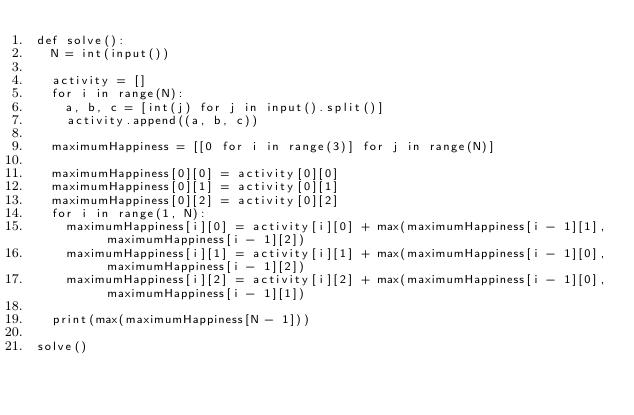Convert code to text. <code><loc_0><loc_0><loc_500><loc_500><_Python_>def solve():
  N = int(input())
  
  activity = []
  for i in range(N):
    a, b, c = [int(j) for j in input().split()]
    activity.append((a, b, c))

  maximumHappiness = [[0 for i in range(3)] for j in range(N)]

  maximumHappiness[0][0] = activity[0][0]
  maximumHappiness[0][1] = activity[0][1]
  maximumHappiness[0][2] = activity[0][2]
  for i in range(1, N):
    maximumHappiness[i][0] = activity[i][0] + max(maximumHappiness[i - 1][1], maximumHappiness[i - 1][2])
    maximumHappiness[i][1] = activity[i][1] + max(maximumHappiness[i - 1][0], maximumHappiness[i - 1][2])
    maximumHappiness[i][2] = activity[i][2] + max(maximumHappiness[i - 1][0], maximumHappiness[i - 1][1])

  print(max(maximumHappiness[N - 1]))

solve()</code> 